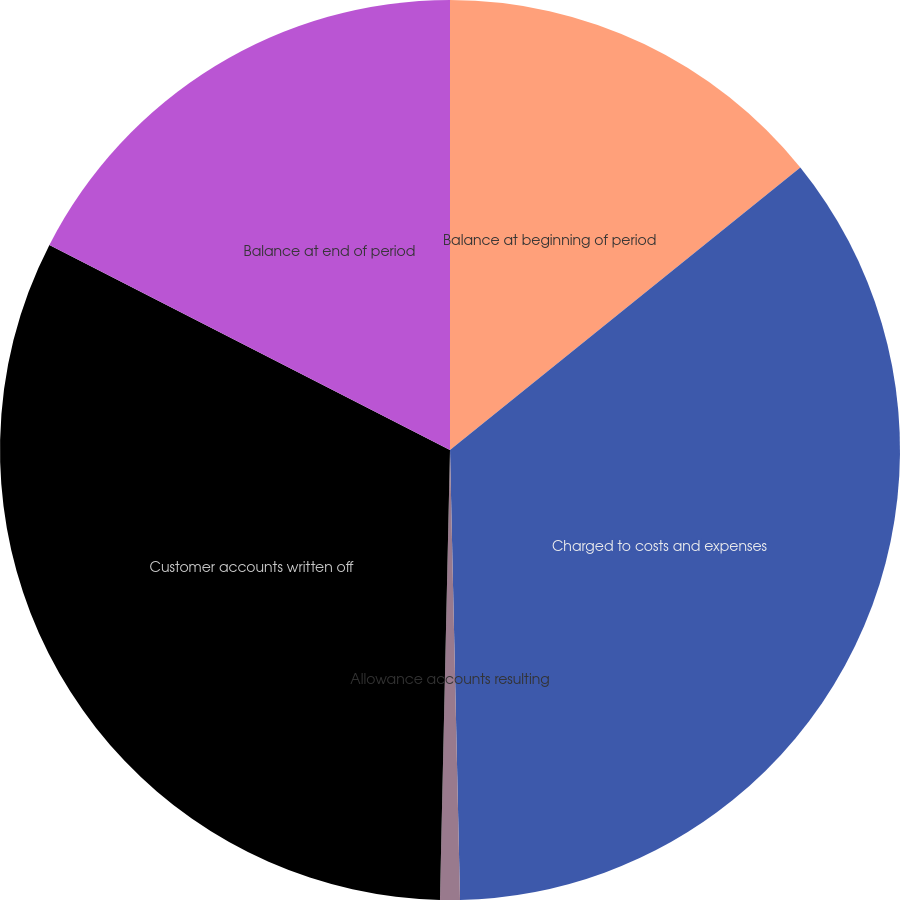Convert chart to OTSL. <chart><loc_0><loc_0><loc_500><loc_500><pie_chart><fcel>Balance at beginning of period<fcel>Charged to costs and expenses<fcel>Allowance accounts resulting<fcel>Customer accounts written off<fcel>Balance at end of period<nl><fcel>14.2%<fcel>35.44%<fcel>0.71%<fcel>32.17%<fcel>17.47%<nl></chart> 